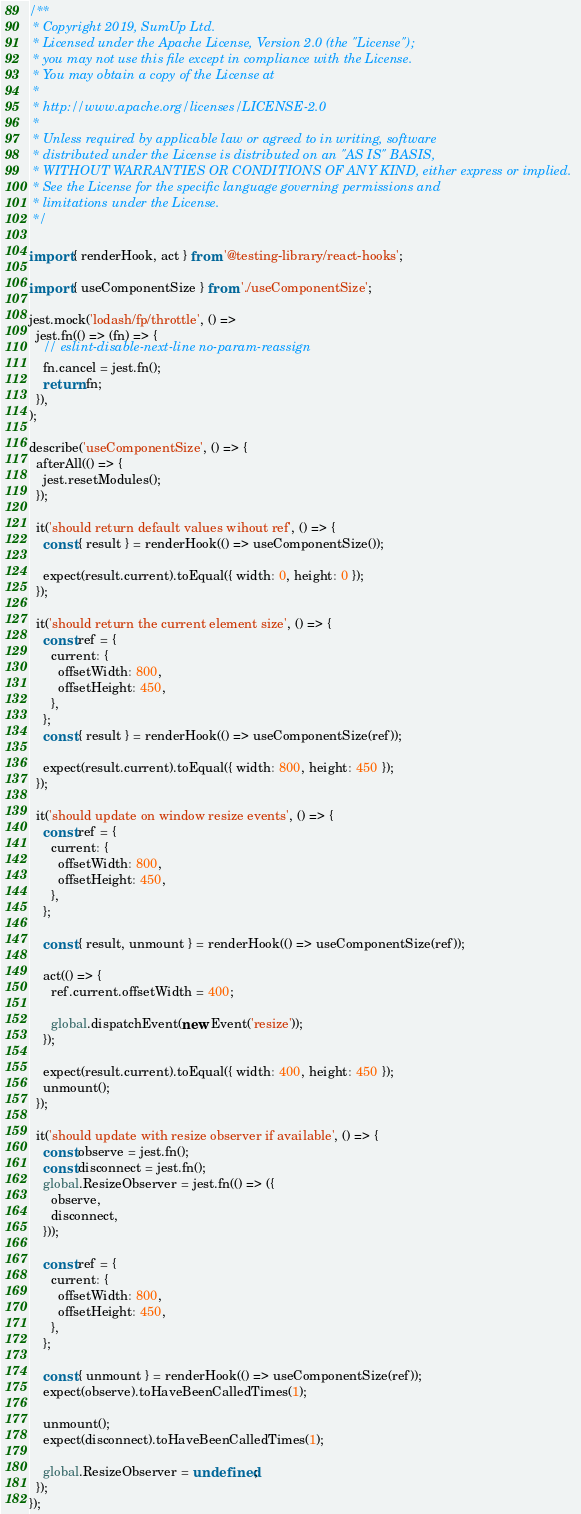Convert code to text. <code><loc_0><loc_0><loc_500><loc_500><_JavaScript_>/**
 * Copyright 2019, SumUp Ltd.
 * Licensed under the Apache License, Version 2.0 (the "License");
 * you may not use this file except in compliance with the License.
 * You may obtain a copy of the License at
 *
 * http://www.apache.org/licenses/LICENSE-2.0
 *
 * Unless required by applicable law or agreed to in writing, software
 * distributed under the License is distributed on an "AS IS" BASIS,
 * WITHOUT WARRANTIES OR CONDITIONS OF ANY KIND, either express or implied.
 * See the License for the specific language governing permissions and
 * limitations under the License.
 */

import { renderHook, act } from '@testing-library/react-hooks';

import { useComponentSize } from './useComponentSize';

jest.mock('lodash/fp/throttle', () =>
  jest.fn(() => (fn) => {
    // eslint-disable-next-line no-param-reassign
    fn.cancel = jest.fn();
    return fn;
  }),
);

describe('useComponentSize', () => {
  afterAll(() => {
    jest.resetModules();
  });

  it('should return default values wihout ref', () => {
    const { result } = renderHook(() => useComponentSize());

    expect(result.current).toEqual({ width: 0, height: 0 });
  });

  it('should return the current element size', () => {
    const ref = {
      current: {
        offsetWidth: 800,
        offsetHeight: 450,
      },
    };
    const { result } = renderHook(() => useComponentSize(ref));

    expect(result.current).toEqual({ width: 800, height: 450 });
  });

  it('should update on window resize events', () => {
    const ref = {
      current: {
        offsetWidth: 800,
        offsetHeight: 450,
      },
    };

    const { result, unmount } = renderHook(() => useComponentSize(ref));

    act(() => {
      ref.current.offsetWidth = 400;

      global.dispatchEvent(new Event('resize'));
    });

    expect(result.current).toEqual({ width: 400, height: 450 });
    unmount();
  });

  it('should update with resize observer if available', () => {
    const observe = jest.fn();
    const disconnect = jest.fn();
    global.ResizeObserver = jest.fn(() => ({
      observe,
      disconnect,
    }));

    const ref = {
      current: {
        offsetWidth: 800,
        offsetHeight: 450,
      },
    };

    const { unmount } = renderHook(() => useComponentSize(ref));
    expect(observe).toHaveBeenCalledTimes(1);

    unmount();
    expect(disconnect).toHaveBeenCalledTimes(1);

    global.ResizeObserver = undefined;
  });
});
</code> 